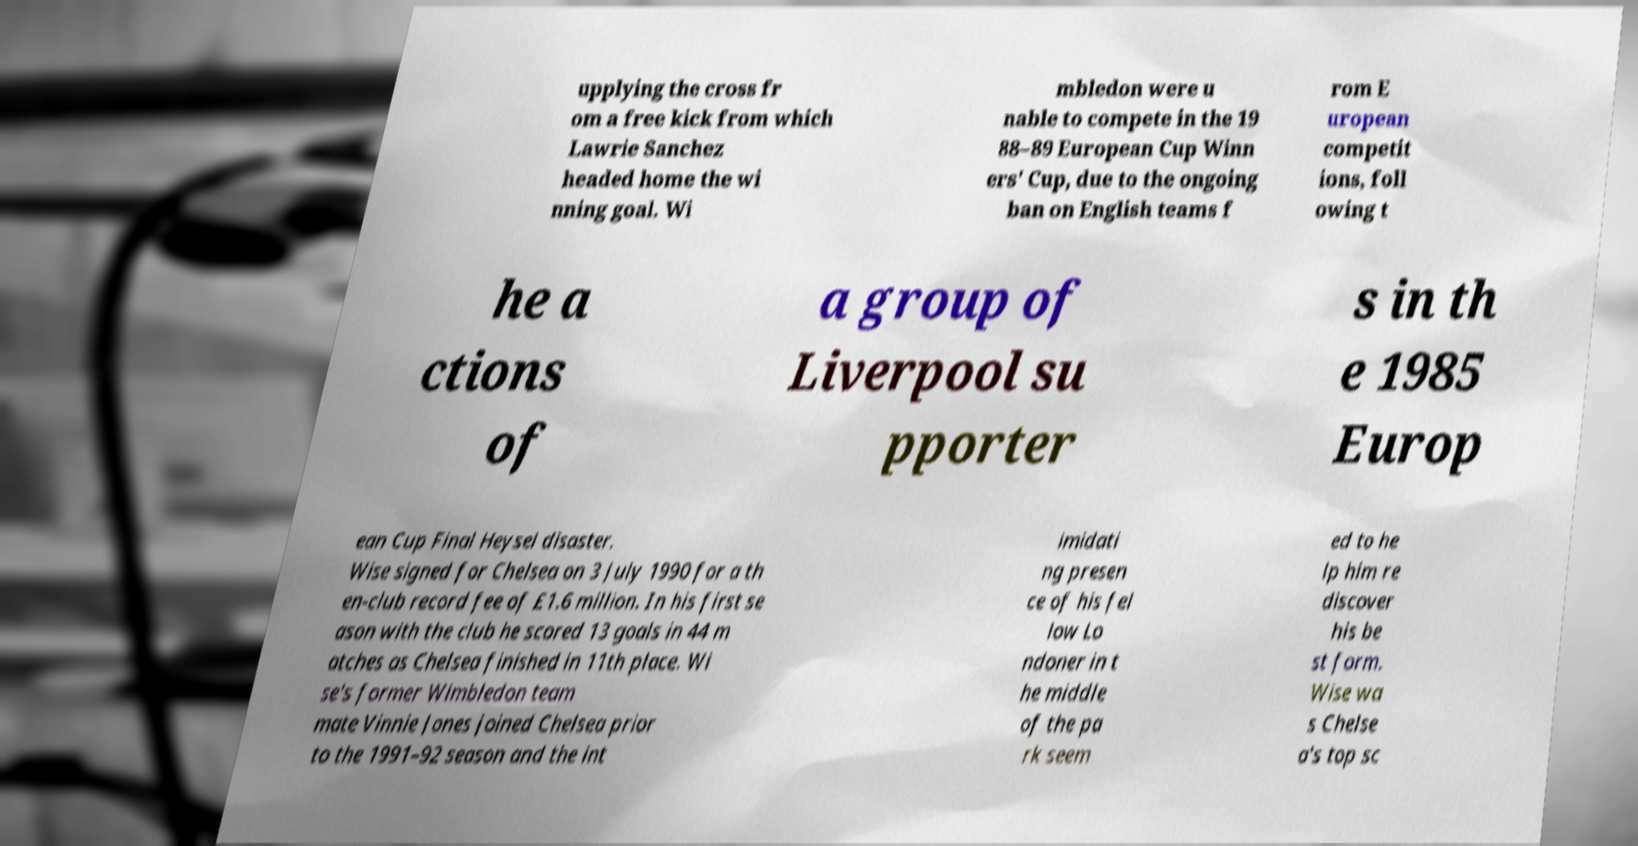Could you extract and type out the text from this image? upplying the cross fr om a free kick from which Lawrie Sanchez headed home the wi nning goal. Wi mbledon were u nable to compete in the 19 88–89 European Cup Winn ers' Cup, due to the ongoing ban on English teams f rom E uropean competit ions, foll owing t he a ctions of a group of Liverpool su pporter s in th e 1985 Europ ean Cup Final Heysel disaster. Wise signed for Chelsea on 3 July 1990 for a th en-club record fee of £1.6 million. In his first se ason with the club he scored 13 goals in 44 m atches as Chelsea finished in 11th place. Wi se's former Wimbledon team mate Vinnie Jones joined Chelsea prior to the 1991–92 season and the int imidati ng presen ce of his fel low Lo ndoner in t he middle of the pa rk seem ed to he lp him re discover his be st form. Wise wa s Chelse a's top sc 